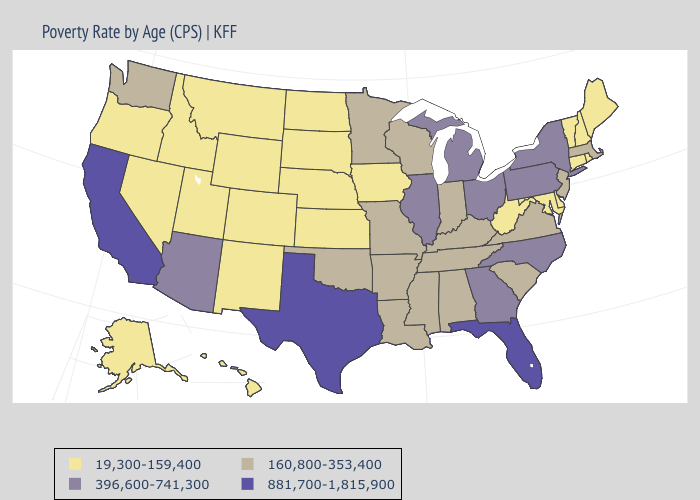Name the states that have a value in the range 160,800-353,400?
Concise answer only. Alabama, Arkansas, Indiana, Kentucky, Louisiana, Massachusetts, Minnesota, Mississippi, Missouri, New Jersey, Oklahoma, South Carolina, Tennessee, Virginia, Washington, Wisconsin. What is the value of Kentucky?
Keep it brief. 160,800-353,400. Which states have the lowest value in the USA?
Keep it brief. Alaska, Colorado, Connecticut, Delaware, Hawaii, Idaho, Iowa, Kansas, Maine, Maryland, Montana, Nebraska, Nevada, New Hampshire, New Mexico, North Dakota, Oregon, Rhode Island, South Dakota, Utah, Vermont, West Virginia, Wyoming. What is the lowest value in states that border Tennessee?
Give a very brief answer. 160,800-353,400. Name the states that have a value in the range 881,700-1,815,900?
Give a very brief answer. California, Florida, Texas. Among the states that border Minnesota , which have the highest value?
Give a very brief answer. Wisconsin. Does the first symbol in the legend represent the smallest category?
Keep it brief. Yes. Does Illinois have the highest value in the MidWest?
Answer briefly. Yes. Does the map have missing data?
Keep it brief. No. What is the lowest value in the USA?
Give a very brief answer. 19,300-159,400. Name the states that have a value in the range 19,300-159,400?
Write a very short answer. Alaska, Colorado, Connecticut, Delaware, Hawaii, Idaho, Iowa, Kansas, Maine, Maryland, Montana, Nebraska, Nevada, New Hampshire, New Mexico, North Dakota, Oregon, Rhode Island, South Dakota, Utah, Vermont, West Virginia, Wyoming. What is the highest value in the MidWest ?
Answer briefly. 396,600-741,300. Does South Carolina have a higher value than New Hampshire?
Write a very short answer. Yes. Name the states that have a value in the range 19,300-159,400?
Answer briefly. Alaska, Colorado, Connecticut, Delaware, Hawaii, Idaho, Iowa, Kansas, Maine, Maryland, Montana, Nebraska, Nevada, New Hampshire, New Mexico, North Dakota, Oregon, Rhode Island, South Dakota, Utah, Vermont, West Virginia, Wyoming. 